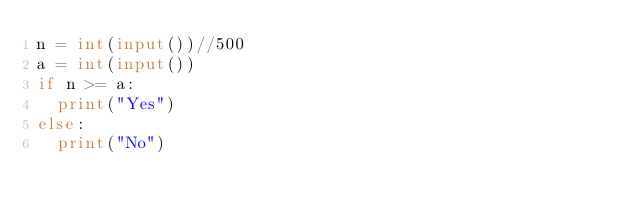<code> <loc_0><loc_0><loc_500><loc_500><_Python_>n = int(input())//500
a = int(input())
if n >= a:
  print("Yes")
else:
  print("No")</code> 